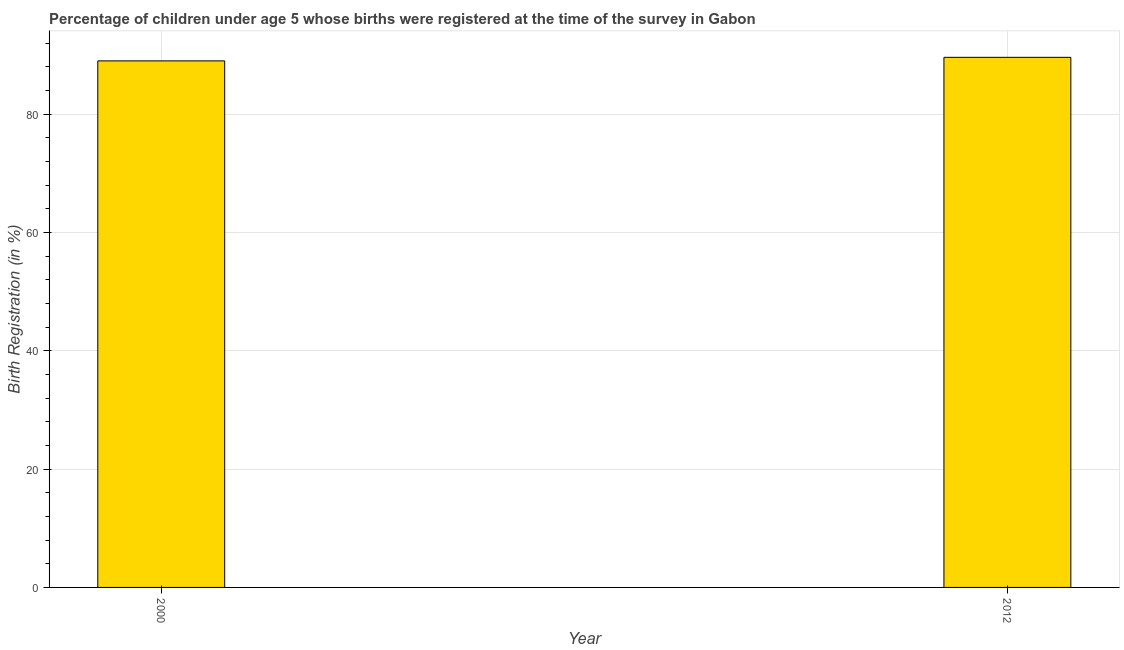What is the title of the graph?
Provide a succinct answer. Percentage of children under age 5 whose births were registered at the time of the survey in Gabon. What is the label or title of the Y-axis?
Give a very brief answer. Birth Registration (in %). What is the birth registration in 2000?
Give a very brief answer. 89. Across all years, what is the maximum birth registration?
Offer a very short reply. 89.6. Across all years, what is the minimum birth registration?
Your answer should be very brief. 89. In which year was the birth registration maximum?
Your response must be concise. 2012. What is the sum of the birth registration?
Provide a short and direct response. 178.6. What is the average birth registration per year?
Provide a short and direct response. 89.3. What is the median birth registration?
Ensure brevity in your answer.  89.3. In how many years, is the birth registration greater than 52 %?
Give a very brief answer. 2. Do a majority of the years between 2000 and 2012 (inclusive) have birth registration greater than 40 %?
Make the answer very short. Yes. In how many years, is the birth registration greater than the average birth registration taken over all years?
Make the answer very short. 1. How many bars are there?
Give a very brief answer. 2. Are all the bars in the graph horizontal?
Your answer should be very brief. No. What is the difference between two consecutive major ticks on the Y-axis?
Your answer should be compact. 20. What is the Birth Registration (in %) of 2000?
Provide a short and direct response. 89. What is the Birth Registration (in %) in 2012?
Provide a short and direct response. 89.6. What is the difference between the Birth Registration (in %) in 2000 and 2012?
Provide a succinct answer. -0.6. 